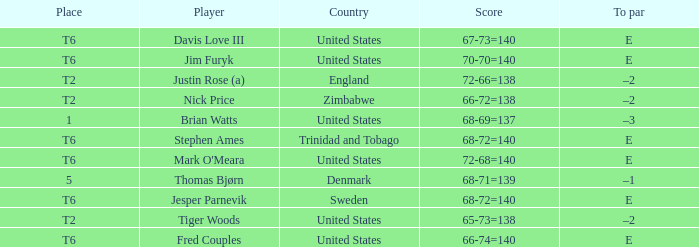The player for which country had a score of 66-72=138? Zimbabwe. 